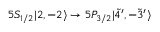<formula> <loc_0><loc_0><loc_500><loc_500>5 S _ { 1 / 2 } | 2 , - 2 \rangle \rightarrow 5 P _ { 3 / 2 } | \tilde { 4 } ^ { \prime } , - \tilde { 3 } ^ { \prime } \rangle</formula> 